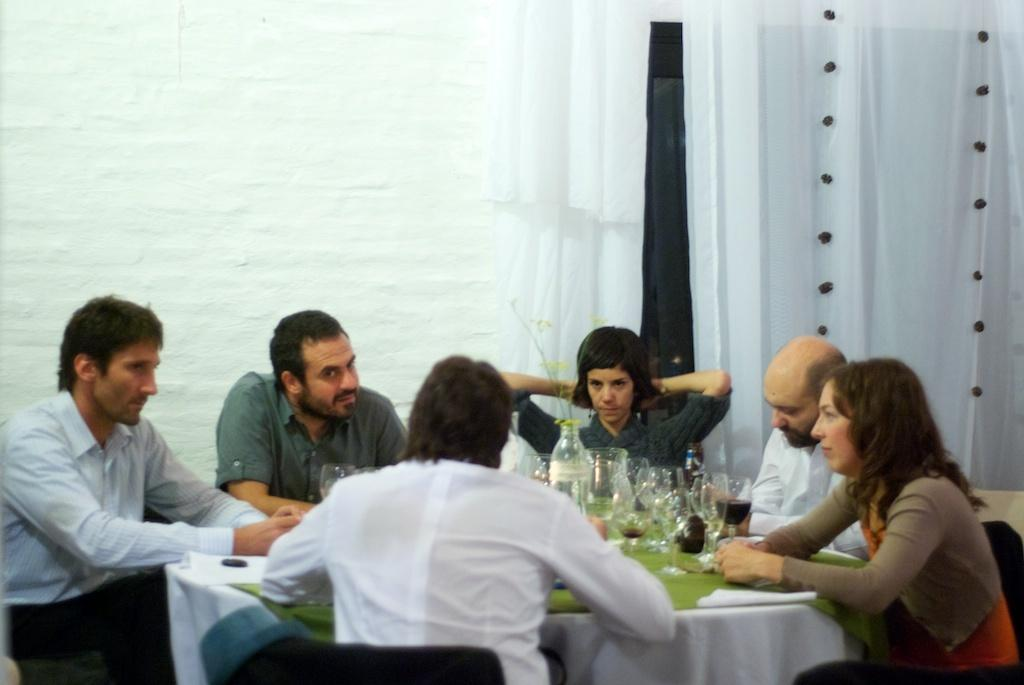What are the people in the image doing? The people in the image are sitting. What are the people sitting on? The people are sitting on chairs. What is present in the image besides the people and chairs? There is a table in the image. What can be seen on the table? There are bottles on the table. What is the appearance of the curtain in the image? There is a white curtain in the image. What type of test is being conducted in the image? There is no test being conducted in the image; it shows people sitting on chairs with a table and bottles. 